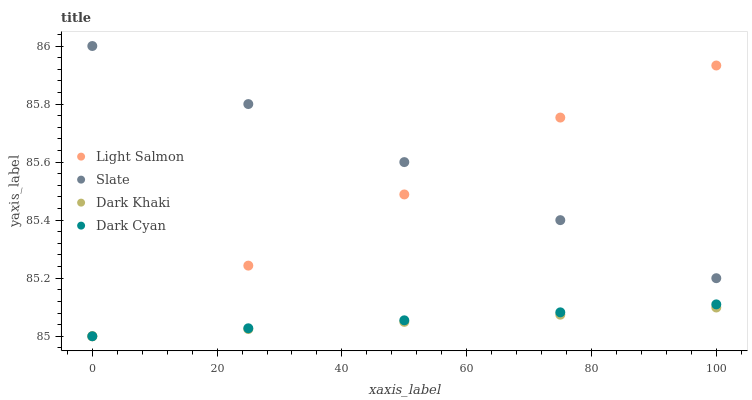Does Dark Khaki have the minimum area under the curve?
Answer yes or no. Yes. Does Slate have the maximum area under the curve?
Answer yes or no. Yes. Does Dark Cyan have the minimum area under the curve?
Answer yes or no. No. Does Dark Cyan have the maximum area under the curve?
Answer yes or no. No. Is Dark Khaki the smoothest?
Answer yes or no. Yes. Is Light Salmon the roughest?
Answer yes or no. Yes. Is Dark Cyan the smoothest?
Answer yes or no. No. Is Dark Cyan the roughest?
Answer yes or no. No. Does Dark Khaki have the lowest value?
Answer yes or no. Yes. Does Slate have the lowest value?
Answer yes or no. No. Does Slate have the highest value?
Answer yes or no. Yes. Does Dark Cyan have the highest value?
Answer yes or no. No. Is Dark Khaki less than Slate?
Answer yes or no. Yes. Is Slate greater than Dark Cyan?
Answer yes or no. Yes. Does Dark Cyan intersect Light Salmon?
Answer yes or no. Yes. Is Dark Cyan less than Light Salmon?
Answer yes or no. No. Is Dark Cyan greater than Light Salmon?
Answer yes or no. No. Does Dark Khaki intersect Slate?
Answer yes or no. No. 